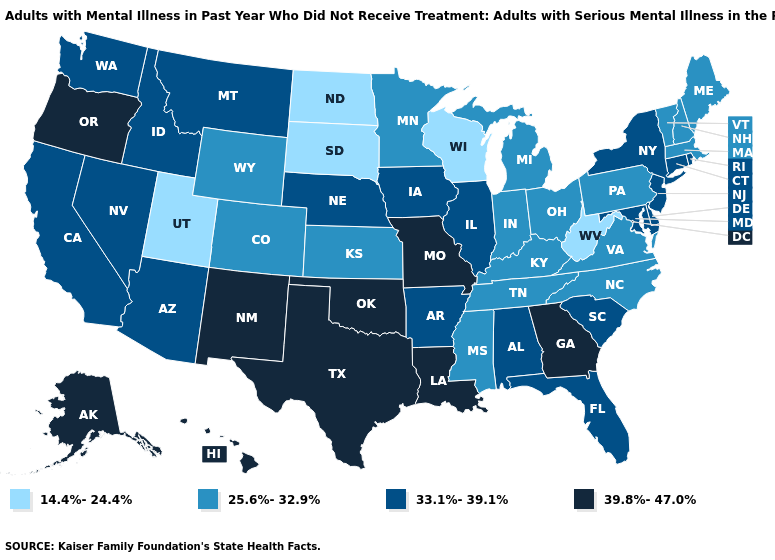Does New Jersey have the highest value in the Northeast?
Answer briefly. Yes. Does Connecticut have the lowest value in the Northeast?
Concise answer only. No. Name the states that have a value in the range 25.6%-32.9%?
Answer briefly. Colorado, Indiana, Kansas, Kentucky, Maine, Massachusetts, Michigan, Minnesota, Mississippi, New Hampshire, North Carolina, Ohio, Pennsylvania, Tennessee, Vermont, Virginia, Wyoming. What is the value of Delaware?
Quick response, please. 33.1%-39.1%. How many symbols are there in the legend?
Quick response, please. 4. Among the states that border Kentucky , which have the highest value?
Keep it brief. Missouri. Which states have the highest value in the USA?
Keep it brief. Alaska, Georgia, Hawaii, Louisiana, Missouri, New Mexico, Oklahoma, Oregon, Texas. Among the states that border Connecticut , which have the highest value?
Be succinct. New York, Rhode Island. Name the states that have a value in the range 25.6%-32.9%?
Write a very short answer. Colorado, Indiana, Kansas, Kentucky, Maine, Massachusetts, Michigan, Minnesota, Mississippi, New Hampshire, North Carolina, Ohio, Pennsylvania, Tennessee, Vermont, Virginia, Wyoming. What is the value of Georgia?
Give a very brief answer. 39.8%-47.0%. Among the states that border Arkansas , does Louisiana have the highest value?
Keep it brief. Yes. Name the states that have a value in the range 14.4%-24.4%?
Write a very short answer. North Dakota, South Dakota, Utah, West Virginia, Wisconsin. Which states hav the highest value in the South?
Be succinct. Georgia, Louisiana, Oklahoma, Texas. How many symbols are there in the legend?
Answer briefly. 4. Name the states that have a value in the range 39.8%-47.0%?
Give a very brief answer. Alaska, Georgia, Hawaii, Louisiana, Missouri, New Mexico, Oklahoma, Oregon, Texas. 